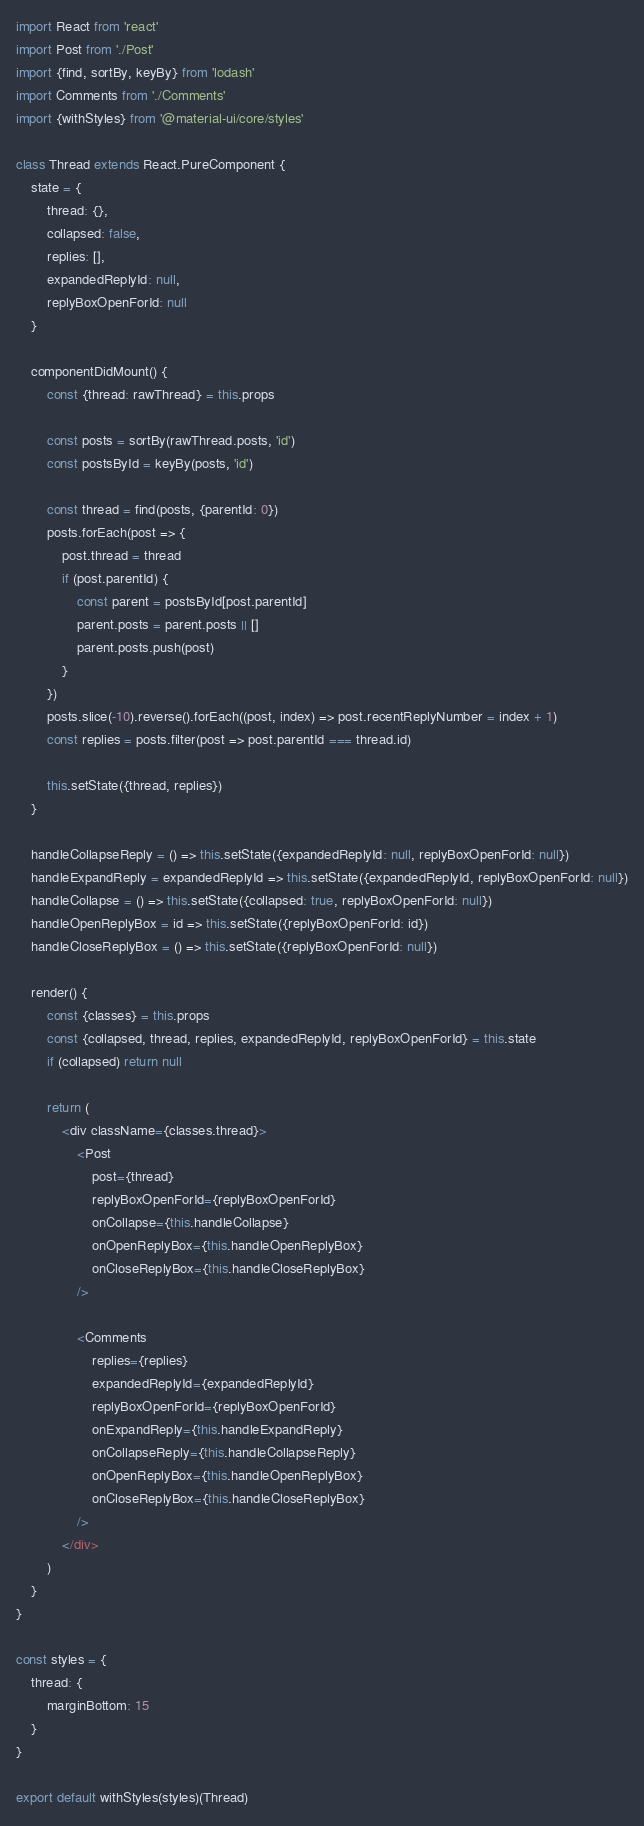Convert code to text. <code><loc_0><loc_0><loc_500><loc_500><_JavaScript_>import React from 'react'
import Post from './Post'
import {find, sortBy, keyBy} from 'lodash'
import Comments from './Comments'
import {withStyles} from '@material-ui/core/styles'

class Thread extends React.PureComponent {
    state = {
        thread: {},
        collapsed: false,
        replies: [],
        expandedReplyId: null,
        replyBoxOpenForId: null
    }

    componentDidMount() {
        const {thread: rawThread} = this.props

        const posts = sortBy(rawThread.posts, 'id')
        const postsById = keyBy(posts, 'id')

        const thread = find(posts, {parentId: 0})
        posts.forEach(post => {
            post.thread = thread
            if (post.parentId) {
                const parent = postsById[post.parentId]
                parent.posts = parent.posts || []
                parent.posts.push(post)
            }
        })
        posts.slice(-10).reverse().forEach((post, index) => post.recentReplyNumber = index + 1)
        const replies = posts.filter(post => post.parentId === thread.id)

        this.setState({thread, replies})
    }

    handleCollapseReply = () => this.setState({expandedReplyId: null, replyBoxOpenForId: null})
    handleExpandReply = expandedReplyId => this.setState({expandedReplyId, replyBoxOpenForId: null})
    handleCollapse = () => this.setState({collapsed: true, replyBoxOpenForId: null})
    handleOpenReplyBox = id => this.setState({replyBoxOpenForId: id})
    handleCloseReplyBox = () => this.setState({replyBoxOpenForId: null})

    render() {
        const {classes} = this.props
        const {collapsed, thread, replies, expandedReplyId, replyBoxOpenForId} = this.state
        if (collapsed) return null

        return (
            <div className={classes.thread}>
                <Post
                    post={thread}
                    replyBoxOpenForId={replyBoxOpenForId}
                    onCollapse={this.handleCollapse}
                    onOpenReplyBox={this.handleOpenReplyBox}
                    onCloseReplyBox={this.handleCloseReplyBox}
                />

                <Comments
                    replies={replies}
                    expandedReplyId={expandedReplyId}
                    replyBoxOpenForId={replyBoxOpenForId}
                    onExpandReply={this.handleExpandReply}
                    onCollapseReply={this.handleCollapseReply}
                    onOpenReplyBox={this.handleOpenReplyBox}
                    onCloseReplyBox={this.handleCloseReplyBox}
                />
            </div>
        )
    }
}

const styles = {
    thread: {
        marginBottom: 15
    }
}

export default withStyles(styles)(Thread)
</code> 